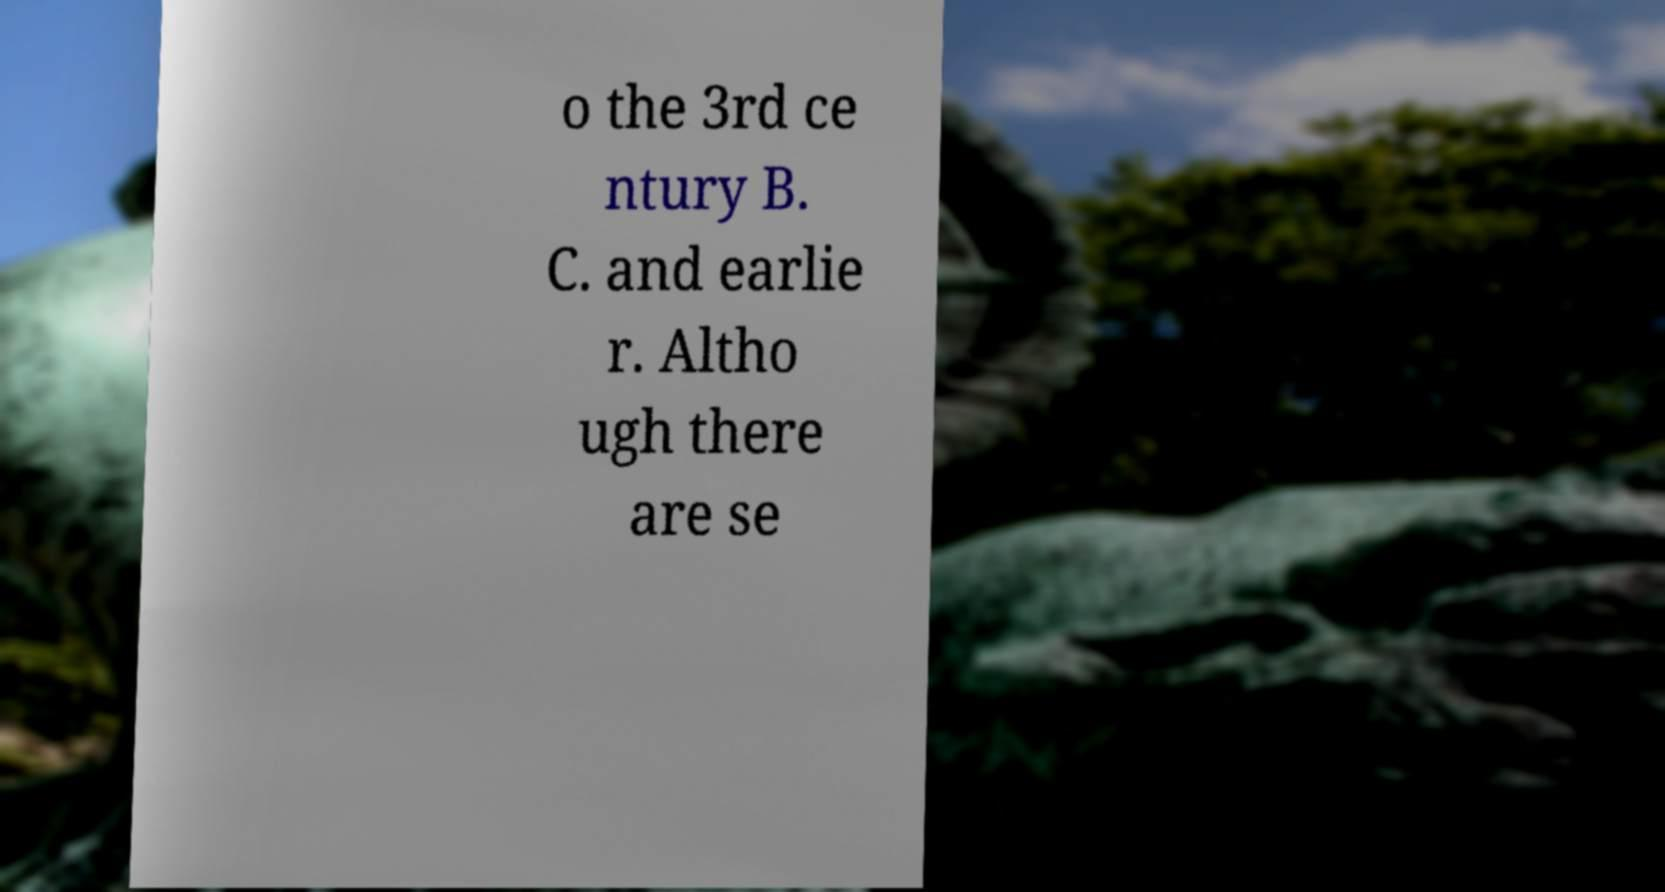Can you accurately transcribe the text from the provided image for me? o the 3rd ce ntury B. C. and earlie r. Altho ugh there are se 